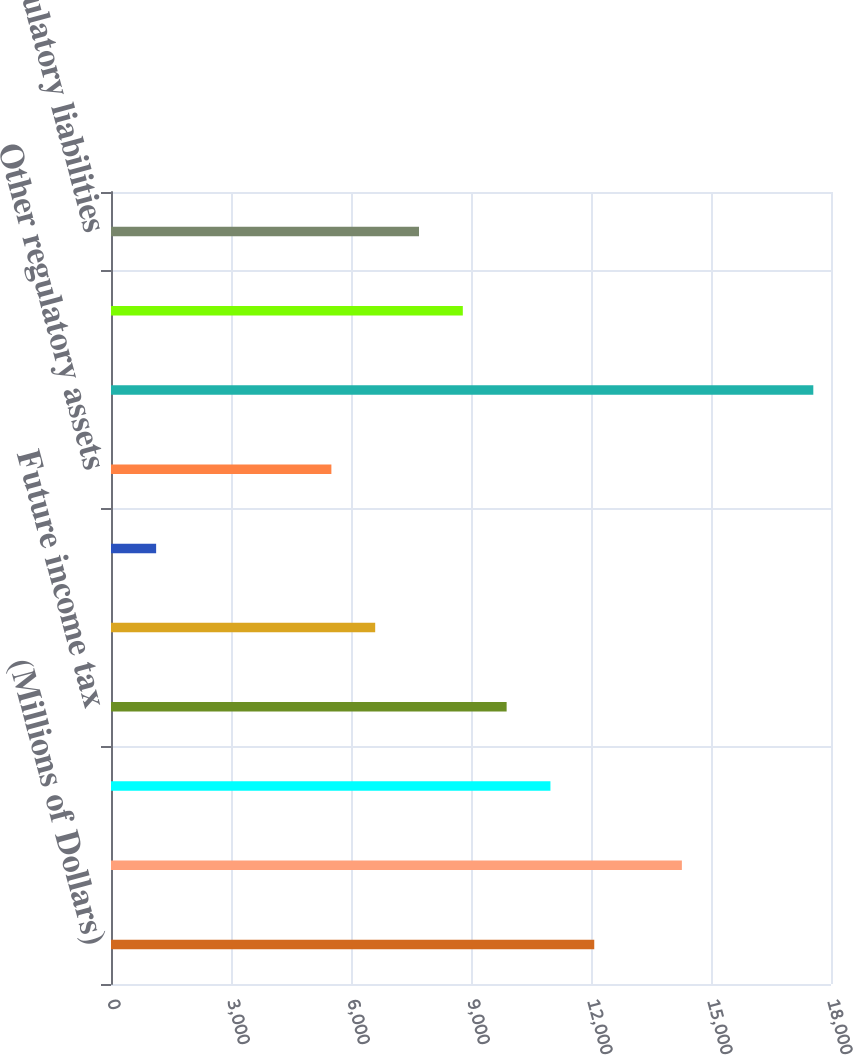<chart> <loc_0><loc_0><loc_500><loc_500><bar_chart><fcel>(Millions of Dollars)<fcel>Property basis differences<fcel>Unrecognized pension and other<fcel>Future income tax<fcel>Environmental remediation<fcel>Deferred storm costs<fcel>Other regulatory assets<fcel>Total deferred tax liabilities<fcel>Accrued pension and other<fcel>Regulatory liabilities<nl><fcel>12081.3<fcel>14271.9<fcel>10986<fcel>9890.7<fcel>6604.8<fcel>1128.3<fcel>5509.5<fcel>17557.8<fcel>8795.4<fcel>7700.1<nl></chart> 